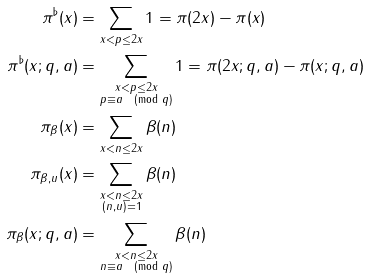<formula> <loc_0><loc_0><loc_500><loc_500>\pi ^ { \flat } ( x ) & = \sum _ { x < p \leq 2 x } 1 = \pi ( 2 x ) - \pi ( x ) \\ \pi ^ { \flat } ( x ; q , a ) & = \sum _ { \substack { x < p \leq 2 x \\ p \equiv a \pmod { q } } } 1 = \pi ( 2 x ; q , a ) - \pi ( x ; q , a ) \\ \pi _ { \beta } ( x ) & = \sum _ { x < n \leq 2 x } \beta ( n ) \\ \pi _ { \beta , u } ( x ) & = \sum _ { \substack { x < n \leq 2 x \\ ( n , u ) = 1 } } \beta ( n ) \\ \pi _ { \beta } ( x ; q , a ) & = \sum _ { \substack { x < n \leq 2 x \\ n \equiv a \pmod { q } } } \beta ( n ) \\</formula> 